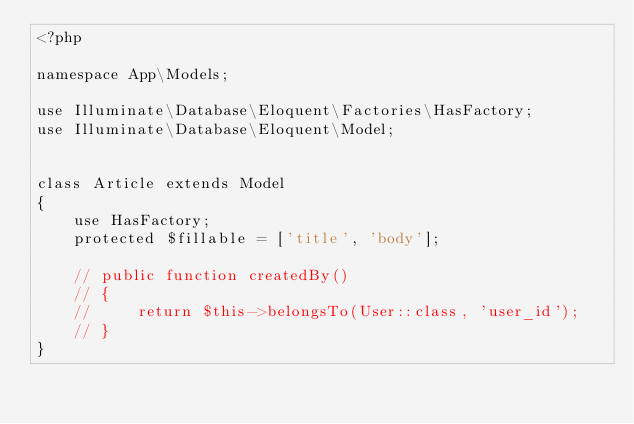<code> <loc_0><loc_0><loc_500><loc_500><_PHP_><?php

namespace App\Models;

use Illuminate\Database\Eloquent\Factories\HasFactory;
use Illuminate\Database\Eloquent\Model;


class Article extends Model
{
    use HasFactory;
    protected $fillable = ['title', 'body'];
    
    // public function createdBy()
    // {
    //     return $this->belongsTo(User::class, 'user_id');
    // }
}
</code> 